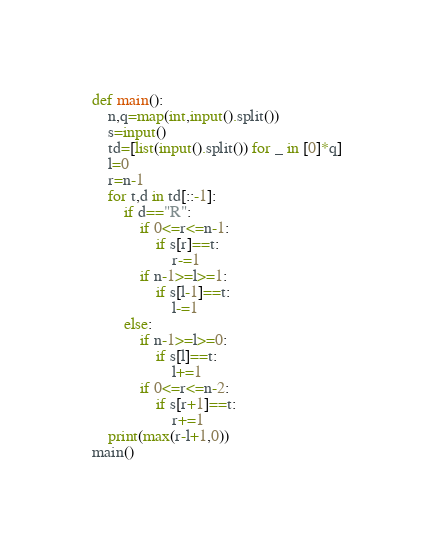Convert code to text. <code><loc_0><loc_0><loc_500><loc_500><_Python_>def main():
    n,q=map(int,input().split())
    s=input()
    td=[list(input().split()) for _ in [0]*q]
    l=0
    r=n-1
    for t,d in td[::-1]:
        if d=="R":
            if 0<=r<=n-1:
                if s[r]==t:
                    r-=1
            if n-1>=l>=1:
                if s[l-1]==t:
                    l-=1
        else:
            if n-1>=l>=0:
                if s[l]==t:
                    l+=1
            if 0<=r<=n-2:
                if s[r+1]==t:
                    r+=1
    print(max(r-l+1,0))
main()</code> 